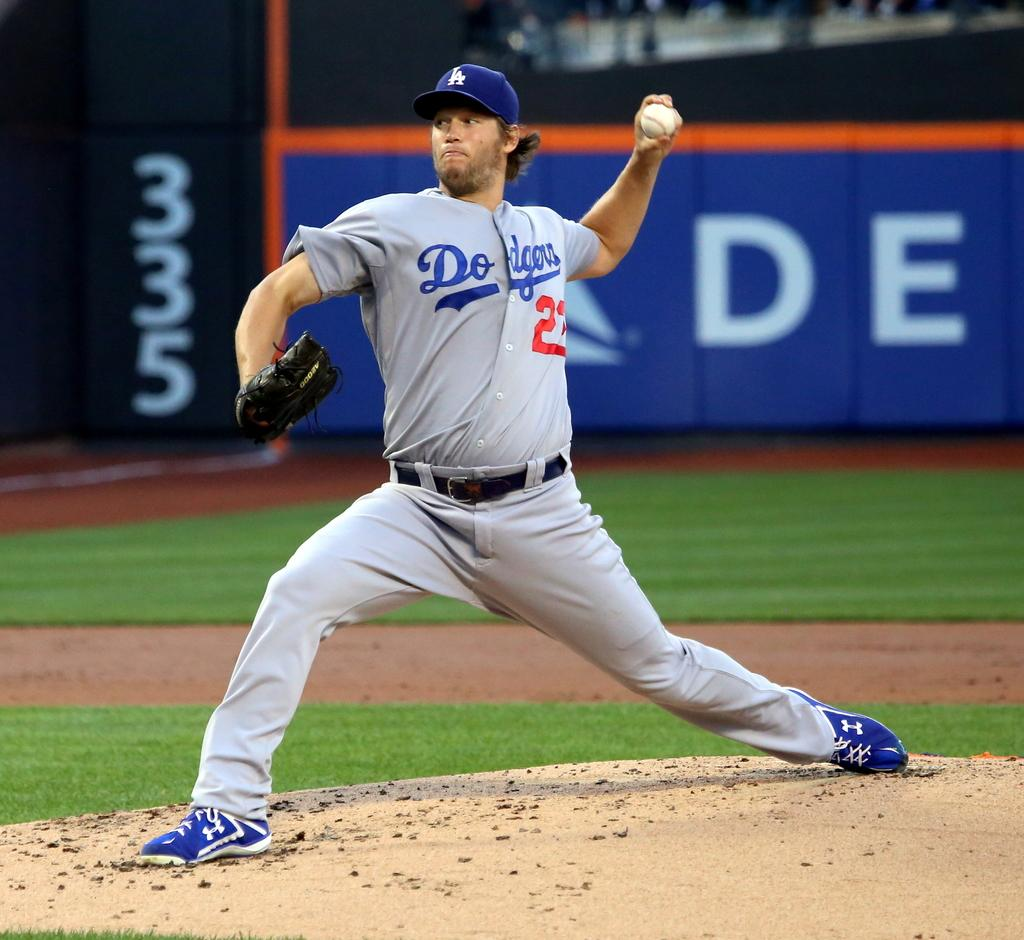<image>
Give a short and clear explanation of the subsequent image. On the mound is Dodgers player number 23. 